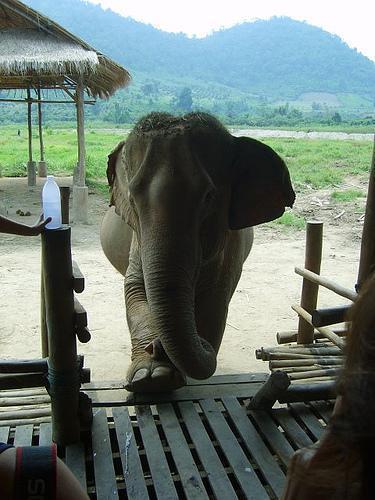How many people are wearing yellow shirt?
Give a very brief answer. 0. 